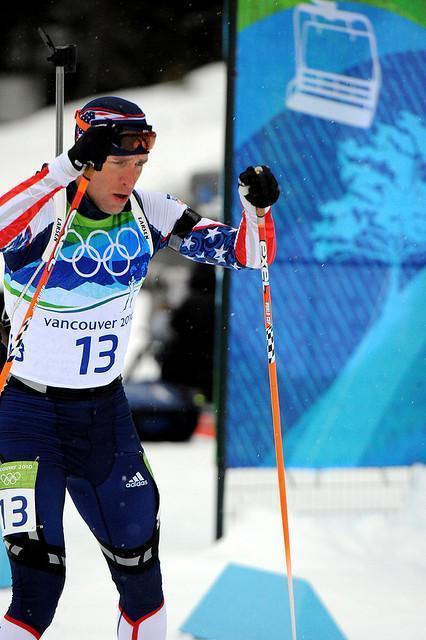How many brown horses are there?
Give a very brief answer. 0. 